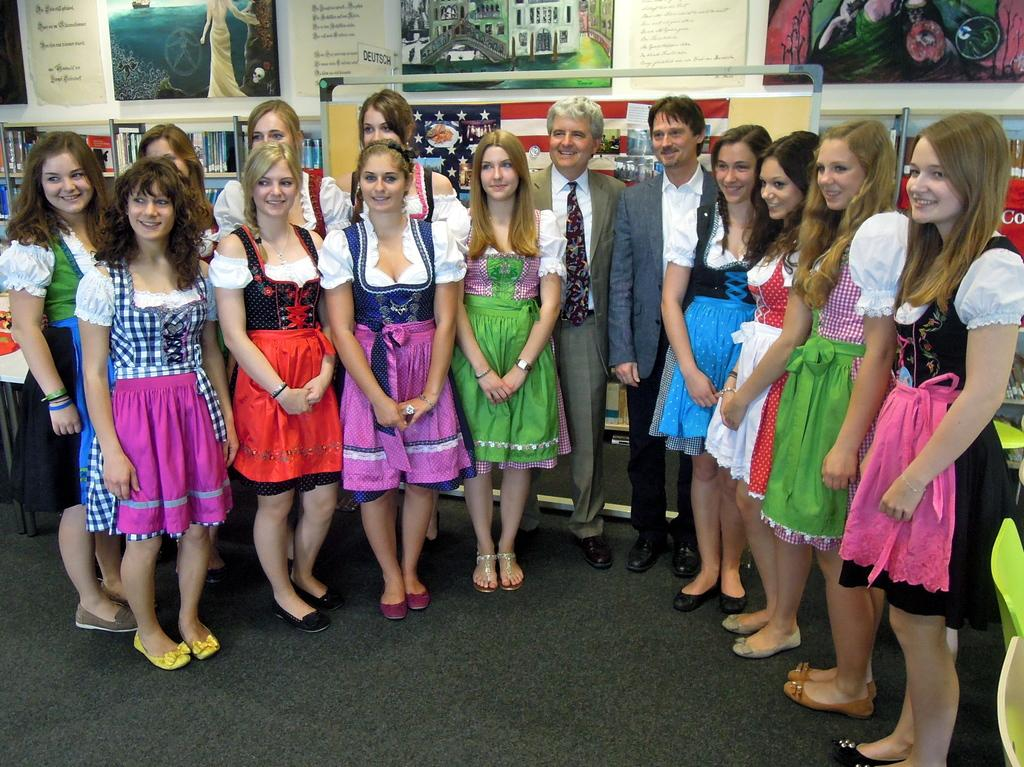How many people are in the image? There is a group of people in the image. Can you describe the person standing in front of the group? The person in front of the group is wearing a brown blazer and white shirt. What can be seen in the background of the image? There are frames attached to the wall in the background of the image. Is there a river flowing through the dinner table in the image? There is no dinner table or river present in the image. 